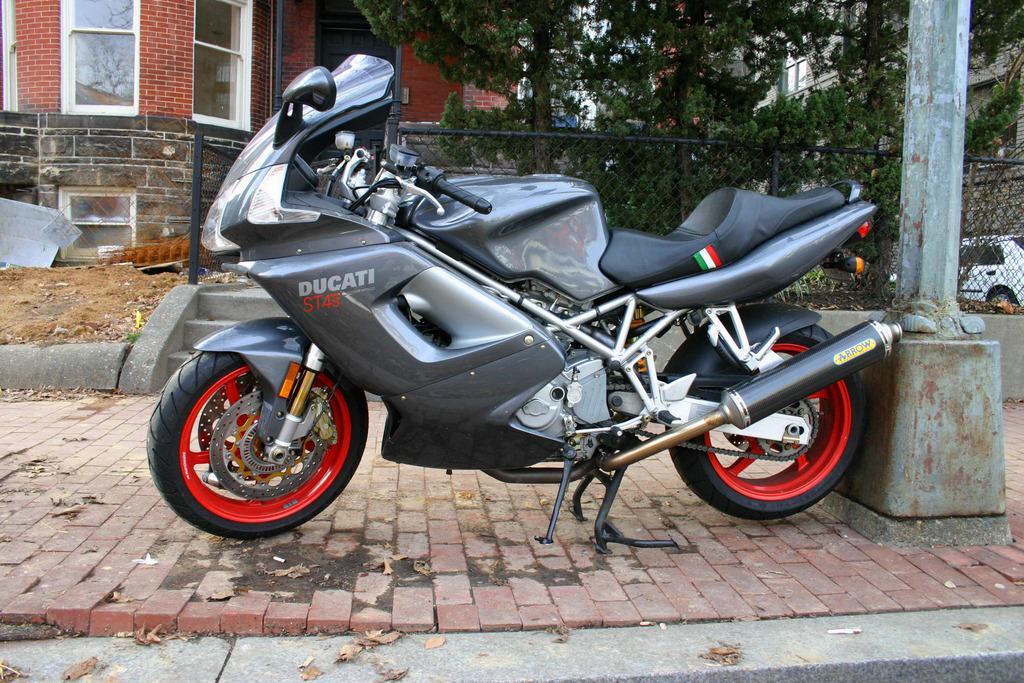Describe this image in one or two sentences. In the middle of the image we can see a motor vehicle placed on the floor. In the background we can see iron mesh, pole, sand, shredded leaves, trees, buildings and a car. 